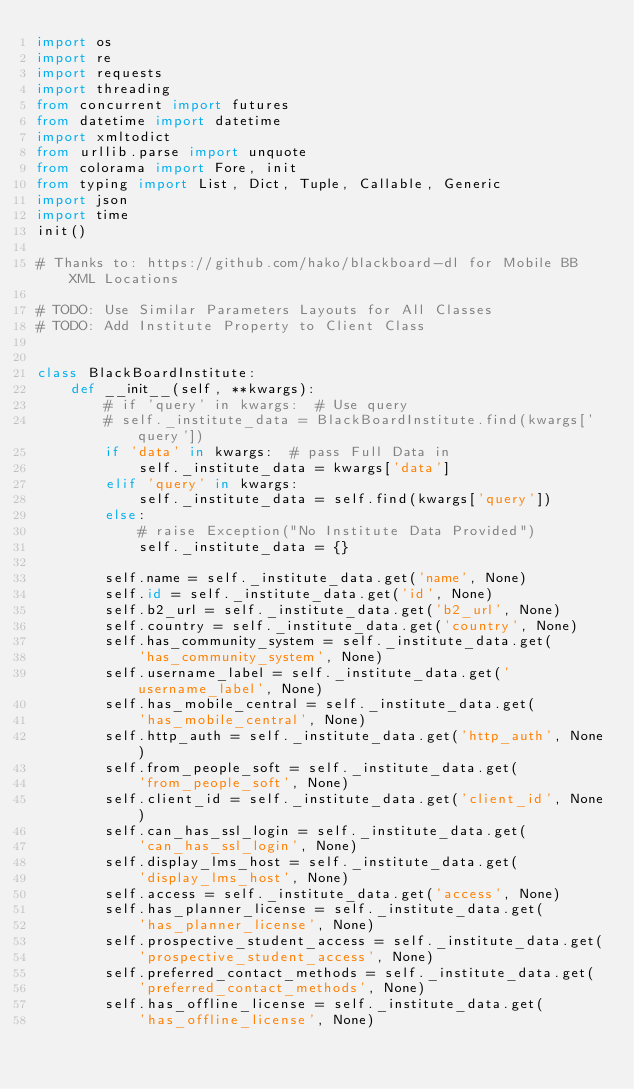<code> <loc_0><loc_0><loc_500><loc_500><_Python_>import os
import re
import requests
import threading
from concurrent import futures
from datetime import datetime
import xmltodict
from urllib.parse import unquote
from colorama import Fore, init
from typing import List, Dict, Tuple, Callable, Generic
import json
import time
init()

# Thanks to: https://github.com/hako/blackboard-dl for Mobile BB XML Locations

# TODO: Use Similar Parameters Layouts for All Classes
# TODO: Add Institute Property to Client Class


class BlackBoardInstitute:
    def __init__(self, **kwargs):
        # if 'query' in kwargs:  # Use query
        # self._institute_data = BlackBoardInstitute.find(kwargs['query'])
        if 'data' in kwargs:  # pass Full Data in
            self._institute_data = kwargs['data']
        elif 'query' in kwargs:
            self._institute_data = self.find(kwargs['query'])
        else:
            # raise Exception("No Institute Data Provided")
            self._institute_data = {}

        self.name = self._institute_data.get('name', None)
        self.id = self._institute_data.get('id', None)
        self.b2_url = self._institute_data.get('b2_url', None)
        self.country = self._institute_data.get('country', None)
        self.has_community_system = self._institute_data.get(
            'has_community_system', None)
        self.username_label = self._institute_data.get('username_label', None)
        self.has_mobile_central = self._institute_data.get(
            'has_mobile_central', None)
        self.http_auth = self._institute_data.get('http_auth', None)
        self.from_people_soft = self._institute_data.get(
            'from_people_soft', None)
        self.client_id = self._institute_data.get('client_id', None)
        self.can_has_ssl_login = self._institute_data.get(
            'can_has_ssl_login', None)
        self.display_lms_host = self._institute_data.get(
            'display_lms_host', None)
        self.access = self._institute_data.get('access', None)
        self.has_planner_license = self._institute_data.get(
            'has_planner_license', None)
        self.prospective_student_access = self._institute_data.get(
            'prospective_student_access', None)
        self.preferred_contact_methods = self._institute_data.get(
            'preferred_contact_methods', None)
        self.has_offline_license = self._institute_data.get(
            'has_offline_license', None)</code> 